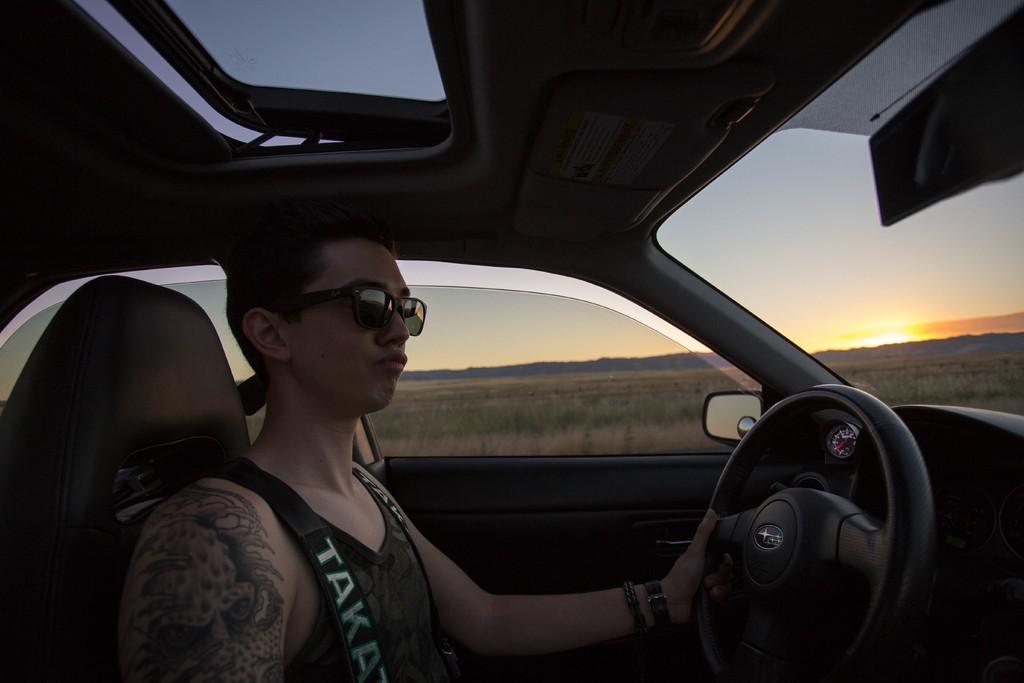Who is the main subject in the image? There is a man in the image. What is the man doing in the image? The man is driving a vehicle. From where is the image taken? The image is taken from inside the vehicle. What can be seen in the background of the image? The sky is visible in the background of the image. Where is the steering wheel located in the image? The steering wheel is on the right side of the image. What type of chalk is the man using to draw shapes on the degree in the image? There is no chalk, degree, or shape present in the image. 